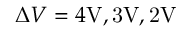<formula> <loc_0><loc_0><loc_500><loc_500>\Delta V = 4 { V } , 3 \mathrm { { V } , 2 \mathrm { V } }</formula> 